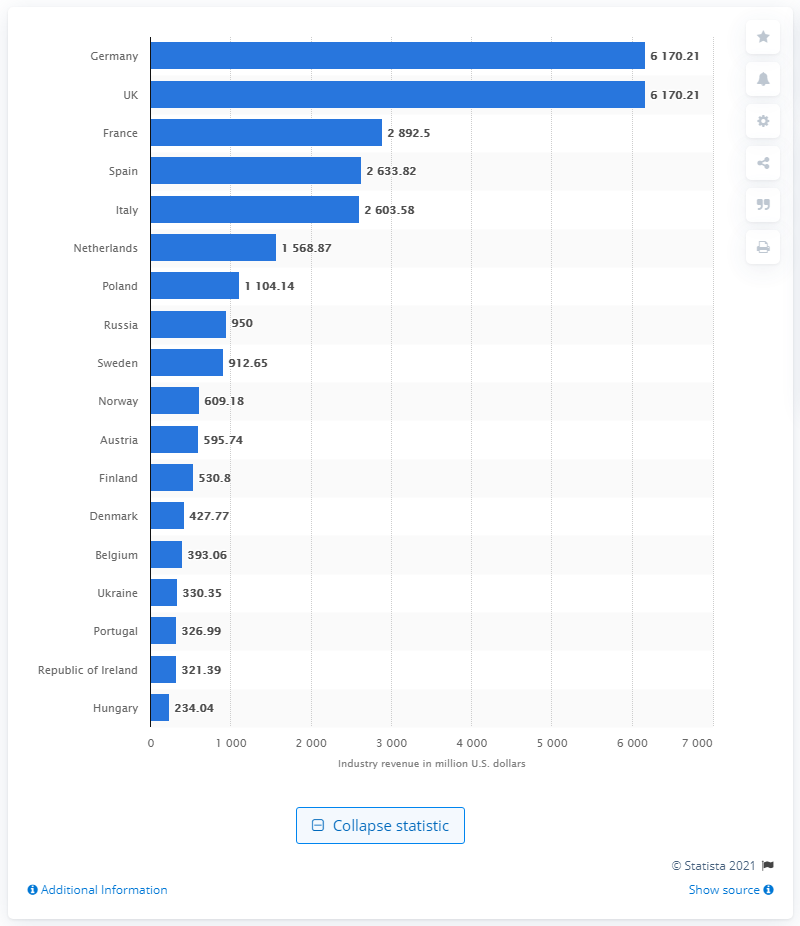Point out several critical features in this image. In 2019, the revenue generated by health clubs in Austria was 595.74 million euros. 